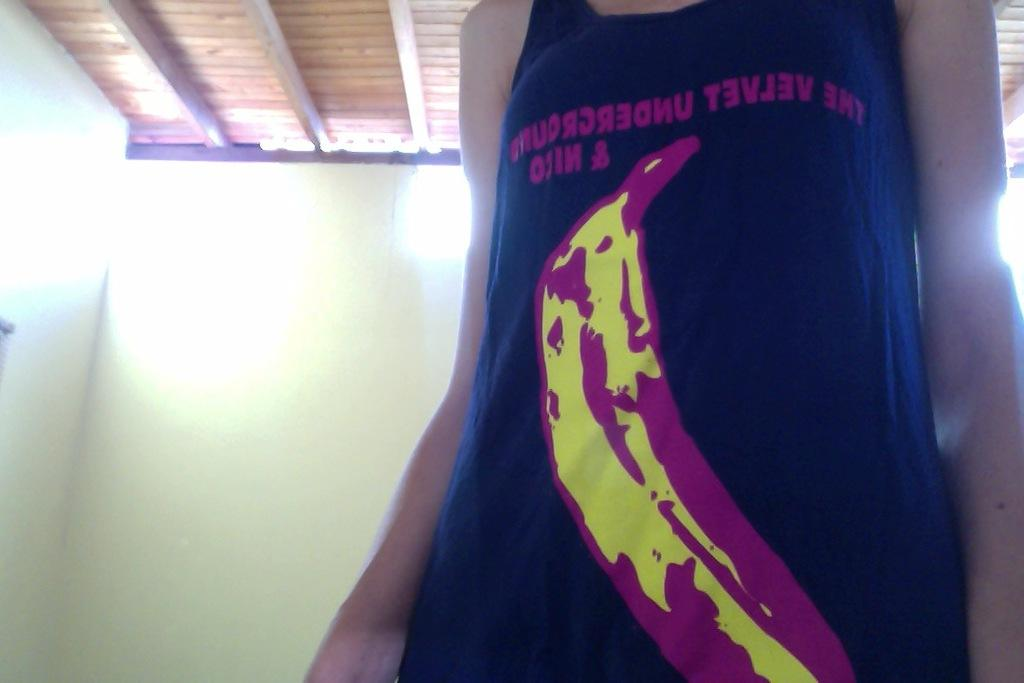<image>
Relay a brief, clear account of the picture shown. The person with blue sleeveless jersey printed  banana picture with the inverted lettering starts The velvet underground 